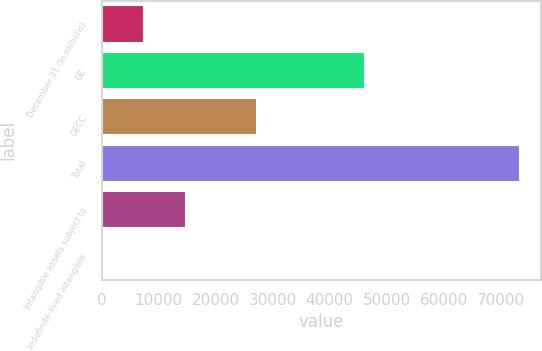Convert chart to OTSL. <chart><loc_0><loc_0><loc_500><loc_500><bar_chart><fcel>December 31 (In millions)<fcel>GE<fcel>GECC<fcel>Total<fcel>Intangible assets subject to<fcel>Indefinite-lived intangible<nl><fcel>7487.8<fcel>46143<fcel>27304<fcel>73447<fcel>14816.6<fcel>159<nl></chart> 